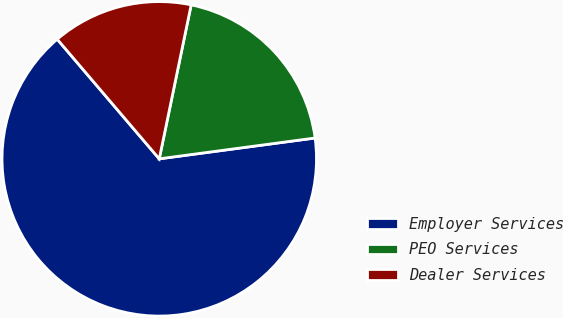<chart> <loc_0><loc_0><loc_500><loc_500><pie_chart><fcel>Employer Services<fcel>PEO Services<fcel>Dealer Services<nl><fcel>65.87%<fcel>19.63%<fcel>14.49%<nl></chart> 